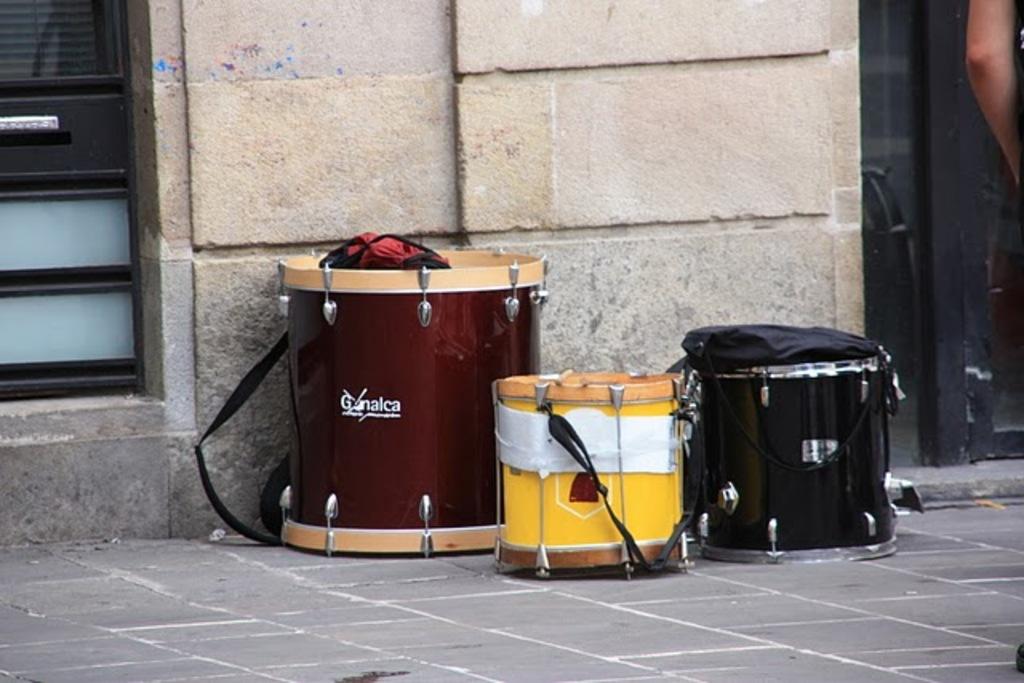Who makes the large red drum?
Keep it short and to the point. Gonalca. 